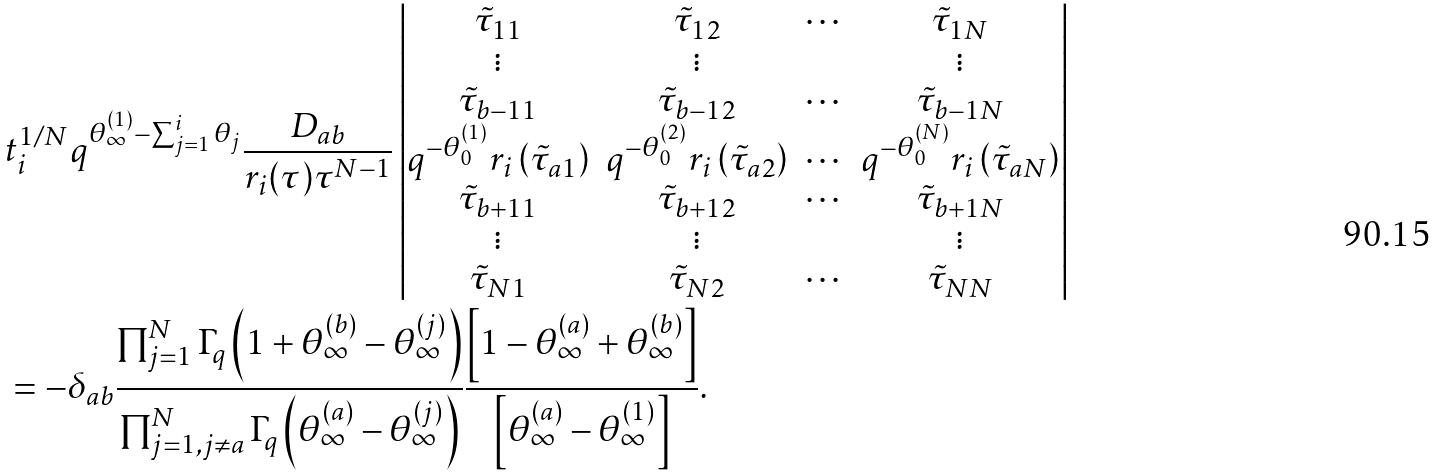<formula> <loc_0><loc_0><loc_500><loc_500>& t _ { i } ^ { 1 / N } q ^ { \theta _ { \infty } ^ { ( 1 ) } - \sum _ { j = 1 } ^ { i } \theta _ { j } } \frac { D _ { a b } } { r _ { i } ( \tau ) \tau ^ { N - 1 } } \left | \begin{matrix} \tilde { \tau } _ { 1 1 } & \tilde { \tau } _ { 1 2 } & \cdots & \tilde { \tau } _ { 1 N } \\ \vdots & \vdots & & \vdots \\ \tilde { \tau } _ { b - 1 1 } & \tilde { \tau } _ { b - 1 2 } & \cdots & \tilde { \tau } _ { b - 1 N } \\ q ^ { - \theta _ { 0 } ^ { ( 1 ) } } r _ { i } \left ( \tilde { \tau } _ { a 1 } \right ) & q ^ { - \theta _ { 0 } ^ { ( 2 ) } } r _ { i } \left ( \tilde { \tau } _ { a 2 } \right ) & \cdots & q ^ { - \theta _ { 0 } ^ { ( N ) } } r _ { i } \left ( \tilde { \tau } _ { a N } \right ) \\ \tilde { \tau } _ { b + 1 1 } & \tilde { \tau } _ { b + 1 2 } & \cdots & \tilde { \tau } _ { b + 1 N } \\ \vdots & \vdots & & \vdots \\ \tilde { \tau } _ { N 1 } & \tilde { \tau } _ { N 2 } & \cdots & \tilde { \tau } _ { N N } \end{matrix} \right | \\ & = - \delta _ { a b } \frac { \prod _ { j = 1 } ^ { N } \Gamma _ { q } \left ( 1 + \theta _ { \infty } ^ { ( b ) } - \theta _ { \infty } ^ { ( j ) } \right ) } { \prod _ { j = 1 , j \neq a } ^ { N } \Gamma _ { q } \left ( \theta _ { \infty } ^ { ( a ) } - \theta _ { \infty } ^ { ( j ) } \right ) } \frac { \left [ 1 - \theta _ { \infty } ^ { ( a ) } + \theta _ { \infty } ^ { ( b ) } \right ] } { \left [ \theta _ { \infty } ^ { ( a ) } - \theta _ { \infty } ^ { ( 1 ) } \right ] } .</formula> 